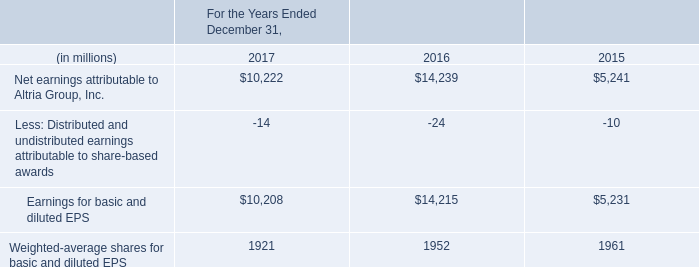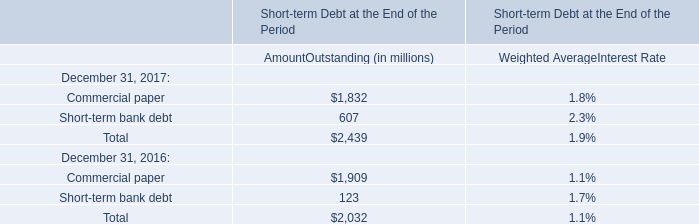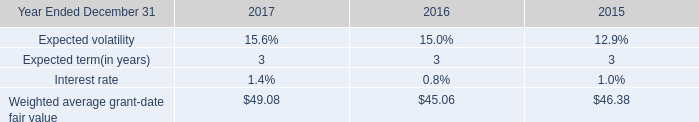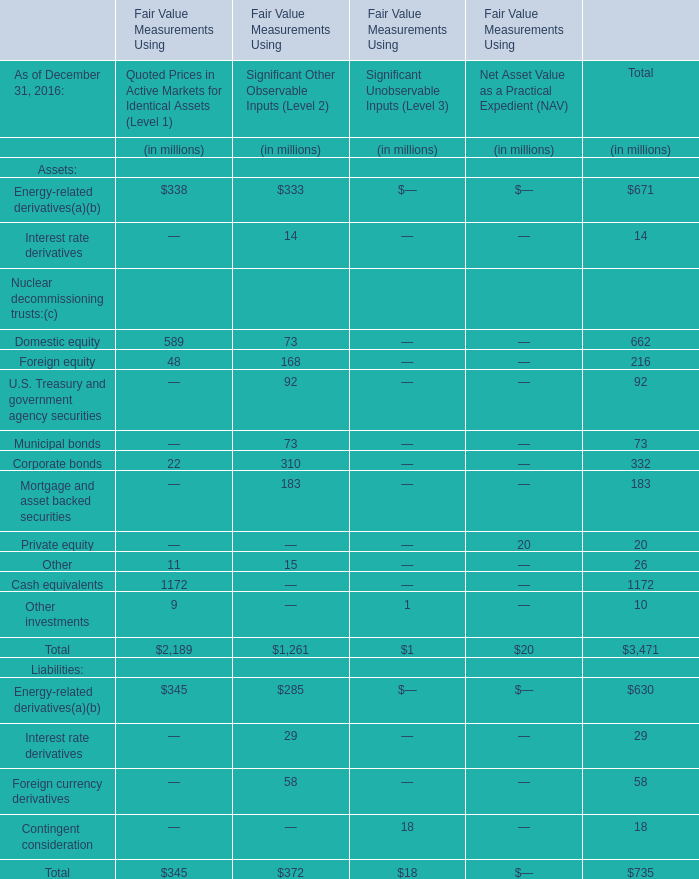What was the average value of the Domestic equity in the years where Energy-related derivatives( is positive for Fair Value Measurements Using? (in million) 
Computations: ((589 + 73) / 2)
Answer: 331.0. 